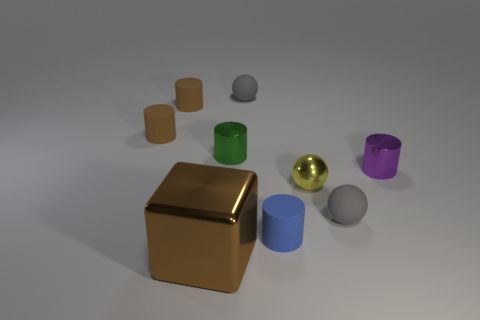Subtract all gray balls. How many balls are left? 1 Add 1 small gray objects. How many objects exist? 10 Subtract all brown cylinders. How many gray balls are left? 2 Subtract all purple cylinders. How many cylinders are left? 4 Subtract all cubes. How many objects are left? 8 Subtract all green spheres. Subtract all blue blocks. How many spheres are left? 3 Add 6 small matte balls. How many small matte balls are left? 8 Add 7 yellow rubber balls. How many yellow rubber balls exist? 7 Subtract 0 gray cylinders. How many objects are left? 9 Subtract all small yellow matte balls. Subtract all large brown objects. How many objects are left? 8 